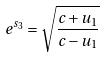<formula> <loc_0><loc_0><loc_500><loc_500>e ^ { s _ { 3 } } = \sqrt { \frac { c + u _ { 1 } } { c - u _ { 1 } } }</formula> 